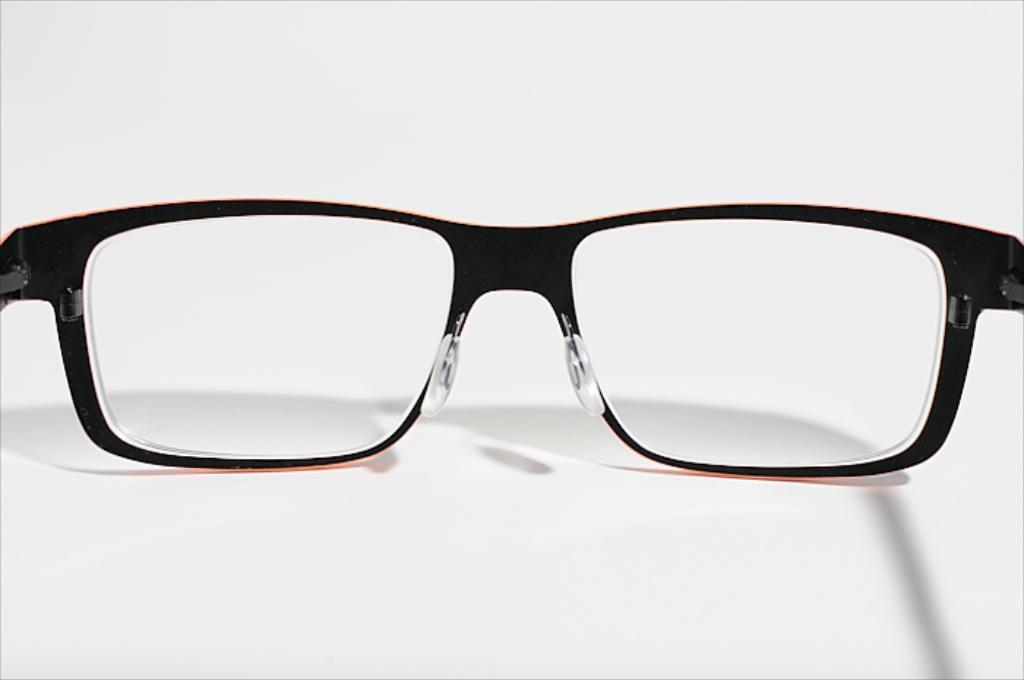What object can be seen in the image? There are spectacles in the image. What color is the background of the image? The background of the image is white. What type of plants can be seen growing on the earth in the image? There are no plants or earth visible in the image; it only features spectacles and a white background. 